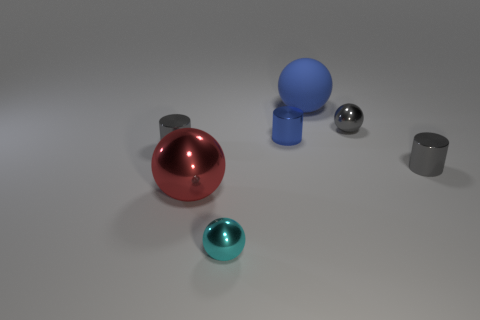Add 3 gray metallic blocks. How many objects exist? 10 Subtract all balls. How many objects are left? 3 Add 4 blue metal things. How many blue metal things exist? 5 Subtract 0 cyan blocks. How many objects are left? 7 Subtract all shiny balls. Subtract all big rubber balls. How many objects are left? 3 Add 3 tiny cyan balls. How many tiny cyan balls are left? 4 